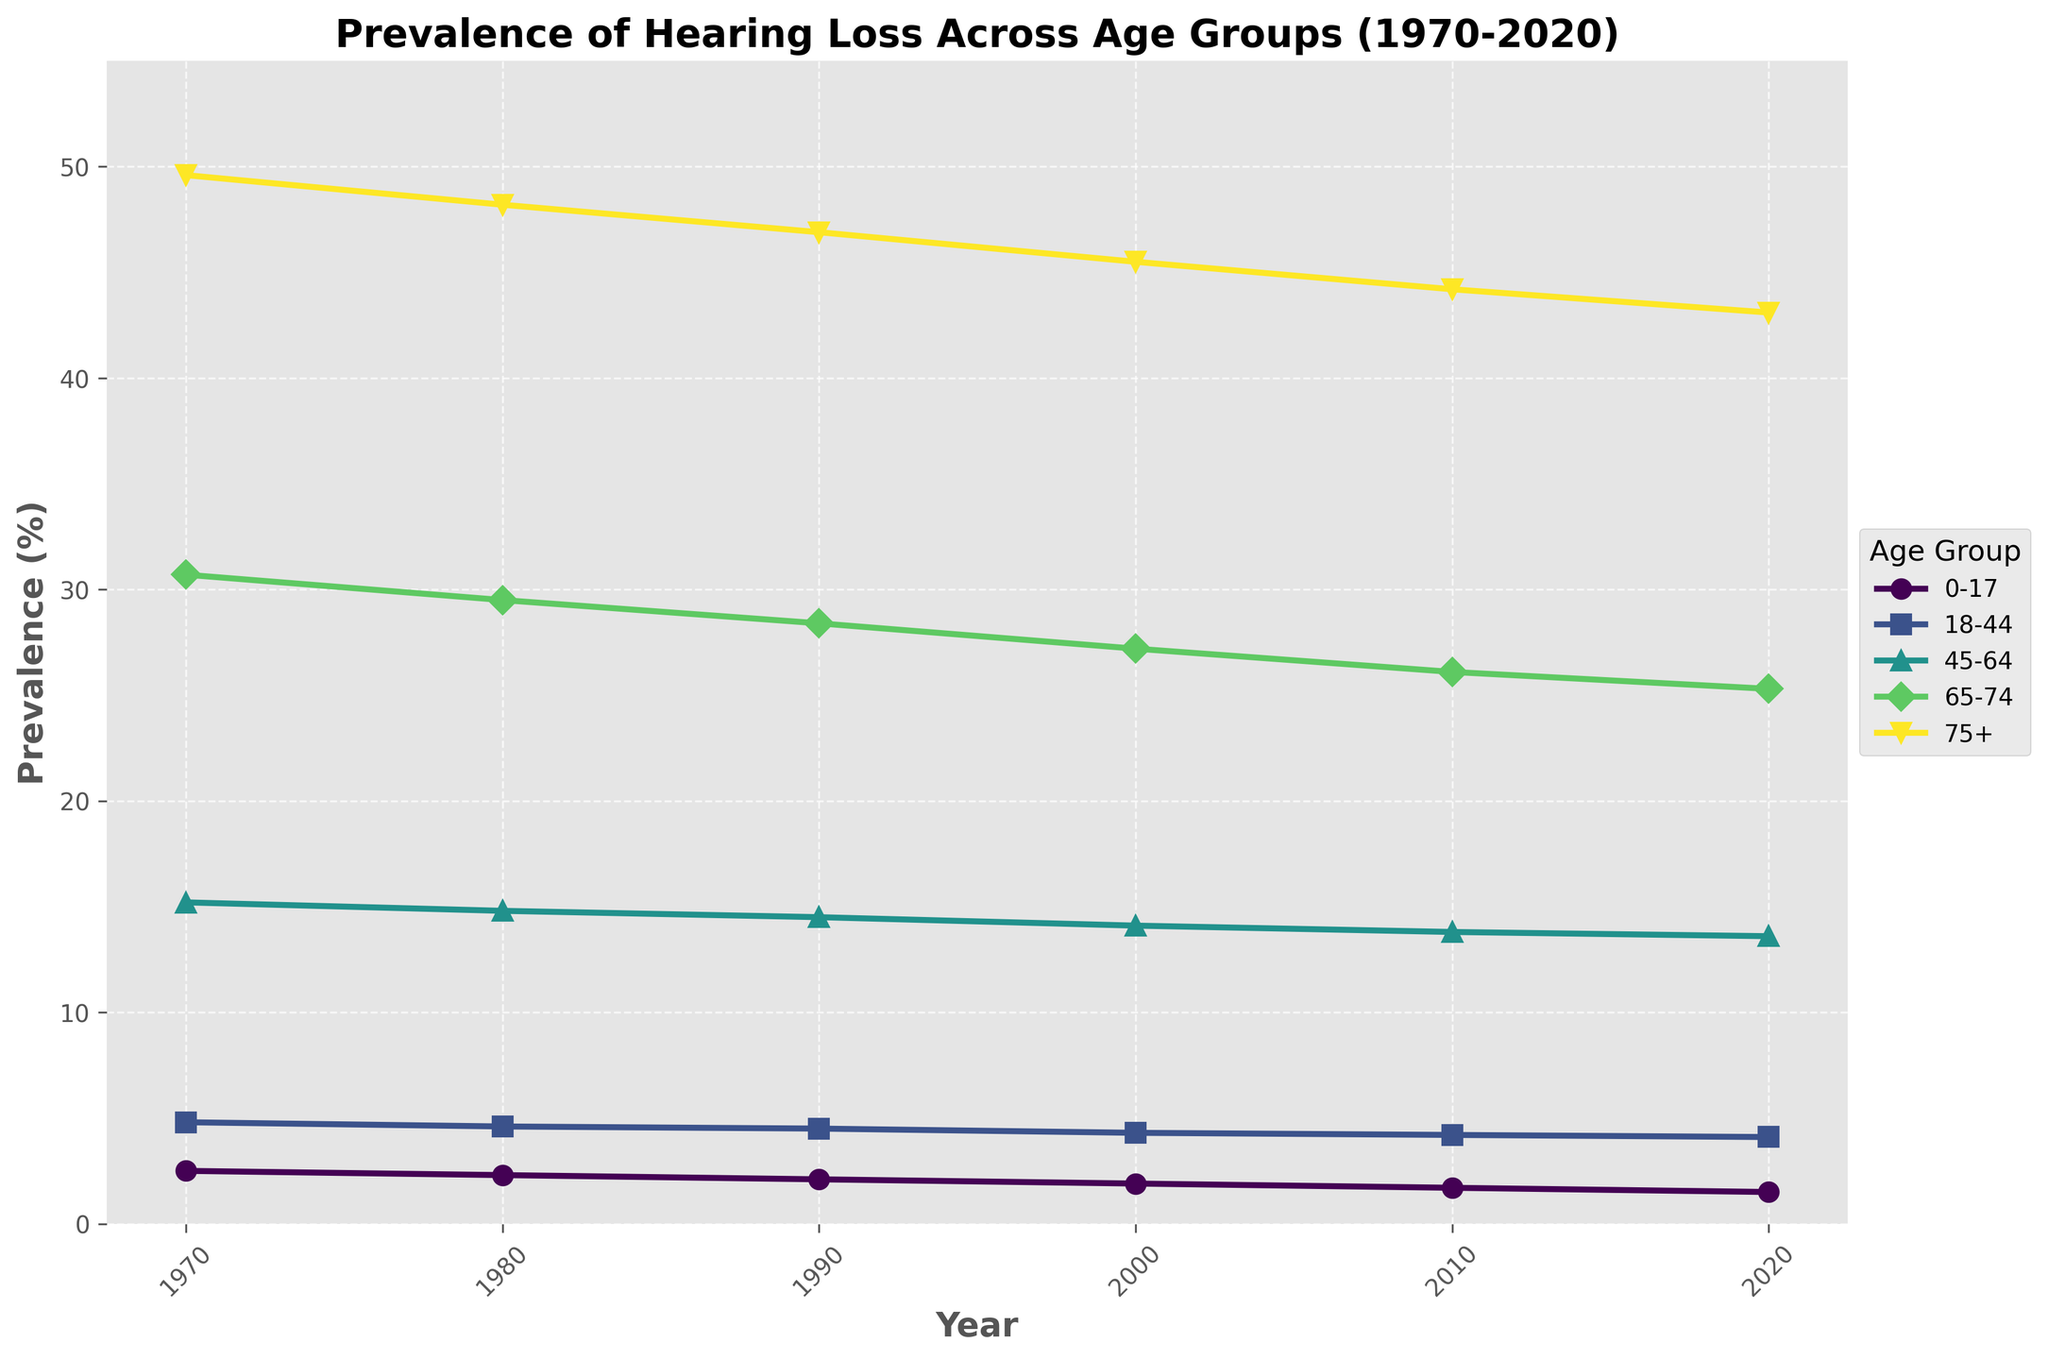What's the trend of hearing loss prevalence in the 0-17 age group from 1970 to 2020? The prevalence of hearing loss in the 0-17 age group decreased consistently from 2.5% in 1970 to 1.5% in 2020. Each decade shows a decline (2.5% to 2.3%, 2.3% to 2.1%, and so on) with the final value at 1.5%.
Answer: A steady decline Which age group had the highest prevalence of hearing loss in each recorded decade? Based on the plot, in each recorded decade (1970, 1980, 1990, etc.), the 75+ age group consistently has the highest prevalence of hearing loss. The prevalence values decrease linearly as the age groups get younger.
Answer: 75+ Between which consecutive decades did the 65-74 age group see the largest decrease in hearing loss prevalence? Look at the difference between consecutive decades for the 65-74 age group: from 30.7 (1970) to 29.5 (1980) is 1.2, from 29.5 to 28.4 (1990) is 1.1, from 28.4 to 27.2 (2000) is 1.2, from 27.2 to 26.1 (2010) is 1.1, from 26.1 to 25.3 (2020) is 0.8. The largest decrease of 1.2% happens between 1970-1980 and 1990-2000.
Answer: 1970-1980 and 1990-2000 What is the average hearing loss prevalence across all age groups in 2020? The prevalence values for 2020 are 1.5%, 4.1%, 13.6%, 25.3%, and 43.1%. Sum these values and divide by the number of age groups: (1.5 + 4.1 + 13.6 + 25.3 + 43.1) / 5 = 17.52%.
Answer: 17.52% Compare the prevalence of hearing loss in the 18-44 and 45-64 age groups in the year 2000. Which has a higher percentage and by how much? In 2000, the prevalence for the 18-44 age group is 4.3% and for the 45-64 age group is 14.1%. Subtract the smaller value from the larger one: 14.1 - 4.3 = 9.8%. The 45-64 age group has a 9.8% higher prevalence.
Answer: 45-64 by 9.8% What is the difference in the hearing loss prevalence for the 75+ age group between 1980 and 2020? In 1980, the prevalence for the 75+ age group is 48.2%, and in 2020 it is 43.1%. Subtract the 2020 value from the 1980 value to find the difference: 48.2 - 43.1 = 5.1%.
Answer: 5.1% How did the prevalence of hearing loss change for the 45-64 age group from 1970 to 2020? The prevalence for the 45-64 age group decreased from 15.2% in 1970 to 13.6% in 2020. The plot shows a generally downward trend over the decades: 15.2%, 14.8%, 14.5%, 14.1%, 13.8%, 13.6%.
Answer: It decreased Imagine a vertical bar corresponding to each age group's prevalence data in 2020. Which age group would have the tallest bar? The tallest bar would represent the age group with the highest prevalence of hearing loss in 2020. According to the plotted data, this is the 75+ age group with a prevalence of 43.1%.
Answer: 75+ By how much did the prevalence of hearing loss decrease in the age group of 45-64 from 1980 to 2000? In 1980, the prevalence for the 45-64 age group is 14.8% and in 2000, it is 14.1%. Subtract the 2000 value from the 1980 value to find the decrease: 14.8 - 14.1 = 0.7%.
Answer: 0.7% 